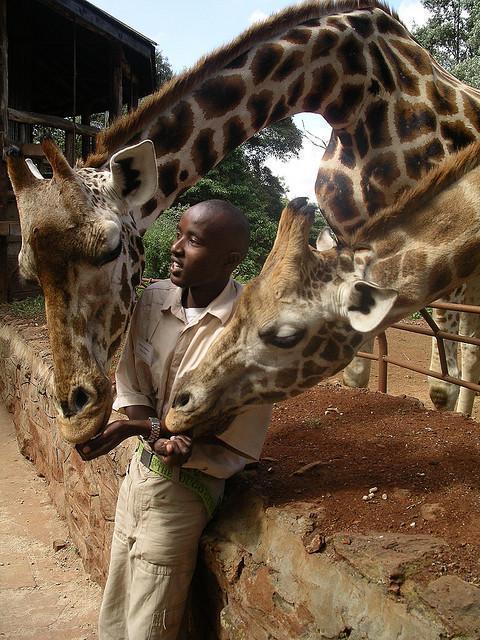What is the man near the giraffes job?
Answer the question by selecting the correct answer among the 4 following choices and explain your choice with a short sentence. The answer should be formatted with the following format: `Answer: choice
Rationale: rationale.`
Options: Businessman, chef, janitor, zookeeper. Answer: zookeeper.
Rationale: The enclosure looks like a zoo and giraffes are typically found in zoos. 